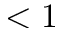Convert formula to latex. <formula><loc_0><loc_0><loc_500><loc_500>< 1</formula> 